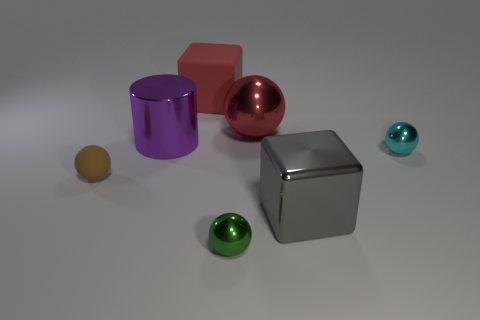Add 1 blue rubber balls. How many objects exist? 8 Subtract all balls. How many objects are left? 3 Subtract all large blue cubes. Subtract all tiny things. How many objects are left? 4 Add 1 metallic things. How many metallic things are left? 6 Add 5 green things. How many green things exist? 6 Subtract 0 cyan blocks. How many objects are left? 7 